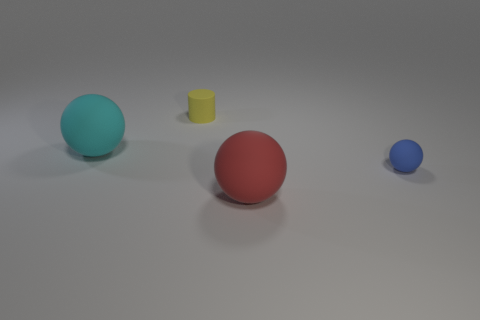How many things are either small cyan rubber objects or cyan matte balls that are to the left of the red matte sphere?
Keep it short and to the point. 1. Are the large cyan object left of the yellow rubber object and the ball on the right side of the red thing made of the same material?
Offer a very short reply. Yes. How many yellow objects are big balls or rubber balls?
Offer a very short reply. 0. The yellow thing has what size?
Offer a very short reply. Small. Is the number of red rubber objects behind the small blue rubber thing greater than the number of green shiny cubes?
Give a very brief answer. No. There is a cyan ball; what number of spheres are to the right of it?
Your response must be concise. 2. Is there a matte ball that has the same size as the red thing?
Offer a very short reply. Yes. What is the color of the other tiny thing that is the same shape as the cyan matte object?
Provide a short and direct response. Blue. Does the sphere in front of the blue object have the same size as the sphere that is left of the large red rubber ball?
Give a very brief answer. Yes. Is there a blue rubber thing of the same shape as the tiny yellow rubber object?
Keep it short and to the point. No. 